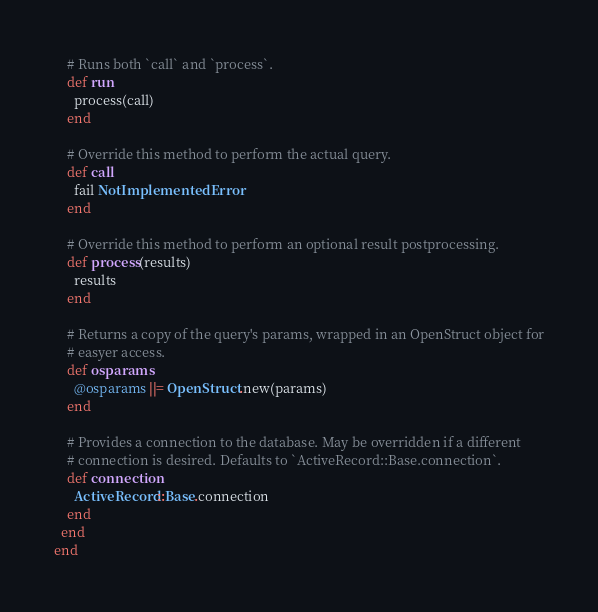<code> <loc_0><loc_0><loc_500><loc_500><_Ruby_>    # Runs both `call` and `process`.
    def run
      process(call)
    end

    # Override this method to perform the actual query.
    def call
      fail NotImplementedError
    end

    # Override this method to perform an optional result postprocessing.
    def process(results)
      results
    end

    # Returns a copy of the query's params, wrapped in an OpenStruct object for
    # easyer access.
    def osparams
      @osparams ||= OpenStruct.new(params)
    end

    # Provides a connection to the database. May be overridden if a different
    # connection is desired. Defaults to `ActiveRecord::Base.connection`.
    def connection
      ActiveRecord::Base.connection
    end
  end
end
</code> 